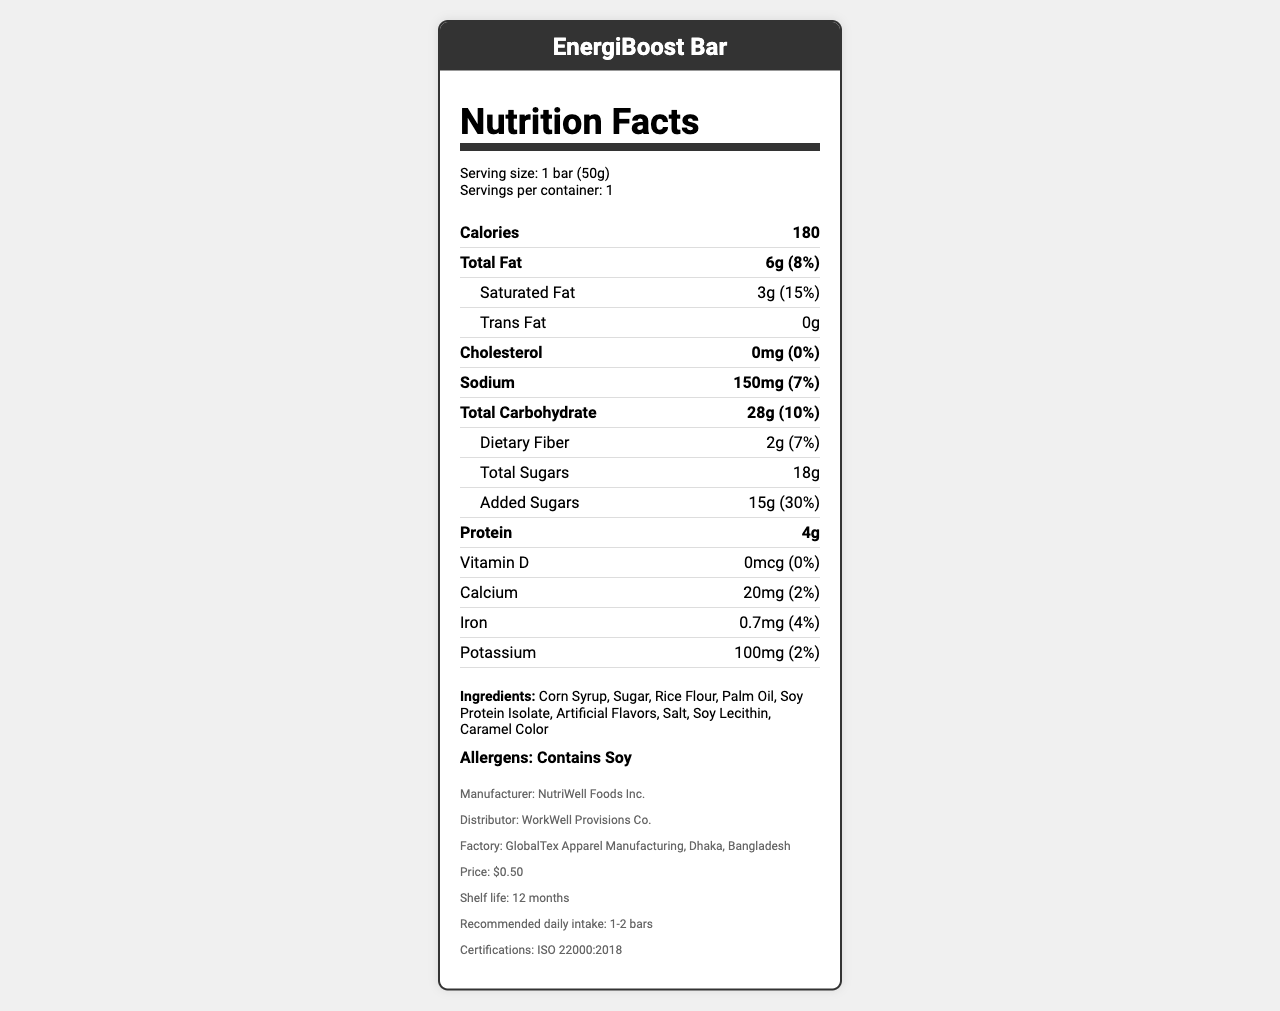what is the calorie content per serving? The calorie content per serving is directly stated as 180 calories in the document.
Answer: 180 what is the percentage daily value of added sugars? The percentage daily value of added sugars is mentioned as 30% in the document.
Answer: 30% which nutrient has the highest daily value percentage? A. Total Fat B. Saturated Fat C. Sodium D. Added Sugars Added sugars have a daily value of 30%, which is higher than total fat (8%), saturated fat (15%), and sodium (7%).
Answer: D. Added Sugars is there any cholesterol in the EnergiBoost Bar? The cholesterol content is listed as 0mg, indicating the EnergiBoost Bar does not contain any cholesterol.
Answer: No what are the main ingredients of the EnergiBoost Bar? The main ingredients listed are Corn Syrup, Sugar, Rice Flour, among others.
Answer: Corn Syrup, Sugar, Rice Flour what is the serving size of the EnergiBoost Bar? The serving size is directly specified as 1 bar (50g) in the document.
Answer: 1 bar (50g) which vitamin or mineral has the lowest daily value percentage? Vitamin D has a daily value percentage of 0%, which is the lowest among the listed vitamins and minerals.
Answer: Vitamin D how many grams of protein are present in one bar? The protein content in one bar is 4 grams as indicated in the document.
Answer: 4g is the EnergiBoost Bar suitable for someone following a low-sugar diet? The EnergiBoost Bar contains 18g of total sugars and 15g of added sugars, which is high for a low-sugar diet.
Answer: No which of the following certifications does the EnergiBoost Bar have? A. USDA Organic B. ISO 22000:2018 C. Non-GMO Project Verified D. Gluten-Free Certified The document states that the product has an ISO 22000:2018 certification.
Answer: B. ISO 22000:2018 what is the recommended daily intake for the EnergiBoost Bar? The document suggests a recommended daily intake of 1-2 bars.
Answer: 1-2 bars does the EnergiBoost Bar contain any allergens? It contains soy, as indicated in the allergen section of the document.
Answer: Yes how much calcium does each bar provide? The calcium content per bar is specified as 20mg in the document.
Answer: 20mg describe the main nutritional concerns of the EnergiBoost Bar The main nutritional concerns are stated in the discrepancies section, highlighting the inadequacies and misleading claims.
Answer: High in added sugars, low in protein and fiber, minimal vitamins and minerals, contains artificial ingredients, and has misleading 'healthy' marketing what is the factory location where the EnergiBoost Bar is manufactured? The factory location is indicated as Dhaka, Bangladesh in the document.
Answer: Dhaka, Bangladesh explain the nutritional value of the EnergiBoost Bar The document details the nutritional breakdown, highlighting high added sugars (30% DV) and saturated fat (15% DV), while lacking substantial amounts of dietary fiber (7% DV), protein (4g), and essential vitamins and minerals.
Answer: The EnergiBoost Bar provides 180 calories per serving, with high levels of added sugars and saturated fat, but minimal protein, fiber, vitamins, and minerals. It contains soy allergens and artificial ingredients, despite being marketed as a healthy snack for busy workers. when was NutriWell Foods Inc. founded? The document does not provide information on the founding date of NutriWell Foods Inc.
Answer: Not enough information 